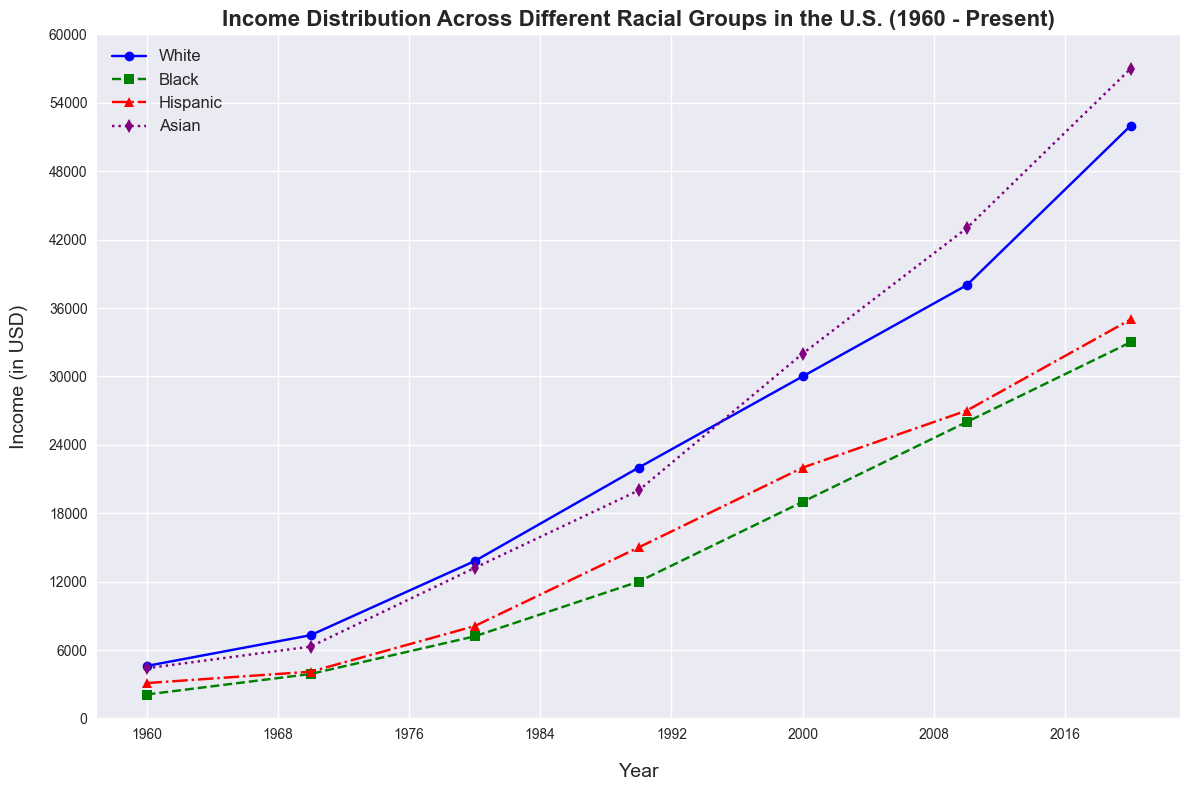What's the trend in income for the Black racial group from 1960 to 2020? Look at the green line with square markers representing the Black racial group. Observe the general direction of the line from 1960 to 2020. The income generally increases over time.
Answer: Increasing Which racial group had the highest income in 1980? Identify the lines corresponding to each racial group in 1980. The purple line with diamond markers (Asian) reaches the highest point among all racial groups this year.
Answer: Asian What is the average income of the Hispanic group in 2000, 2010, and 2020? Find the income values for the Hispanic group in 2000 (22000), 2010 (27000), and 2020 (35000). Calculate the average: (22000 + 27000 + 35000) / 3 = 28000.
Answer: 28000 In which decade did the income for the White racial group see the largest increase? Compare the differences between each consecutive decade for the White group using the blue line. The largest increase is between 2010 (38000) and 2020 (52000), which is 14000.
Answer: 2010-2020 How many times did the Asian racial group have higher income than the White racial group in the given years? Compare the income values for the Asian and White groups year by year. In 1960, 1970, and 2020, the Asian group has higher income than the White group.
Answer: 3 times What color represents the Hispanic racial group in the figure? Identify the line with triangular markers, which is labeled as Hispanic. The color of this line is red.
Answer: Red Which racial group had the lowest income in 1970? Identify the lowest point among the four groups in 1970. The green line with square markers (Black) represents the lowest income in this year.
Answer: Black What was the combined income of the Black and Hispanic groups in 1990? Sum the incomes for Black (12000) and Hispanic (15000) groups in 1990: 12000 + 15000 = 27000.
Answer: 27000 What year did the Hispanic group see their income meet or exceed 20000? Identify the red line for the Hispanic group and trace where it meets or exceeds the 20000 mark. This happens in the year 2000.
Answer: 2000 Compare the income increase of the Asian and White groups between 1980 and 1990. Which group had a larger increase? Calculate the increase for both groups: for Asian (20000 - 13200 = 6800) and for White (22000 - 13800 = 8200). The White group had a larger increase.
Answer: White 